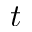<formula> <loc_0><loc_0><loc_500><loc_500>t</formula> 